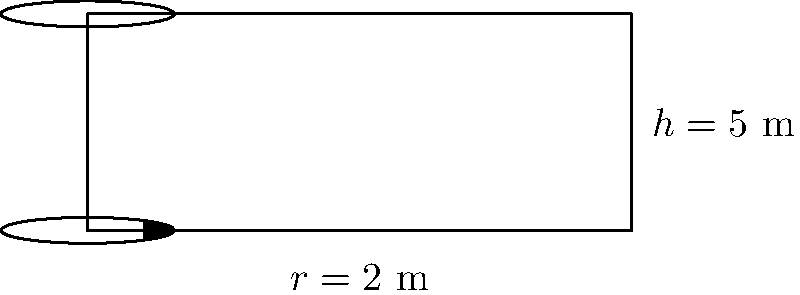As a former PLAAF pilot, you're tasked with calculating the total surface area of a cylindrical fuel tank for a new aircraft design. The tank has a radius of 2 meters and a height of 5 meters. What is the total surface area of the fuel tank in square meters? Round your answer to two decimal places. To calculate the total surface area of a cylindrical fuel tank, we need to consider three parts:

1. The lateral surface area (side of the cylinder)
2. The area of the top circular base
3. The area of the bottom circular base

Let's solve this step-by-step:

1. Lateral surface area:
   * Formula: $A_{lateral} = 2\pi rh$
   * $A_{lateral} = 2\pi \cdot 2 \cdot 5 = 20\pi$ m²

2. Area of one circular base:
   * Formula: $A_{base} = \pi r^2$
   * $A_{base} = \pi \cdot 2^2 = 4\pi$ m²

3. Total surface area:
   * $A_{total} = A_{lateral} + 2A_{base}$
   * $A_{total} = 20\pi + 2(4\pi) = 28\pi$ m²

4. Convert to numerical value and round:
   * $A_{total} = 28 \cdot 3.14159... \approx 87.96$ m²

Therefore, the total surface area of the fuel tank is approximately 87.96 square meters.
Answer: 87.96 m² 